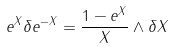<formula> <loc_0><loc_0><loc_500><loc_500>e ^ { X } \delta e ^ { - X } = \frac { 1 - e ^ { X } } X \wedge \delta X</formula> 